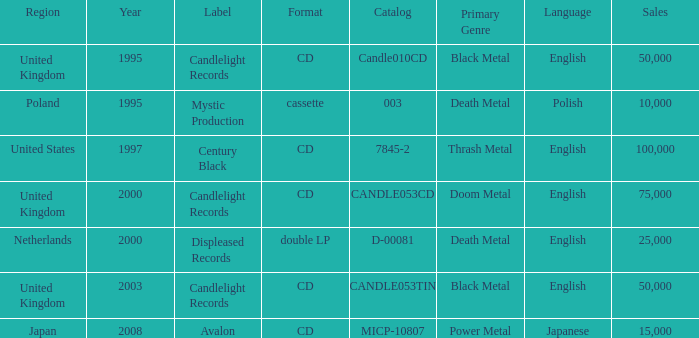What is Candlelight Records format? CD, CD, CD. 